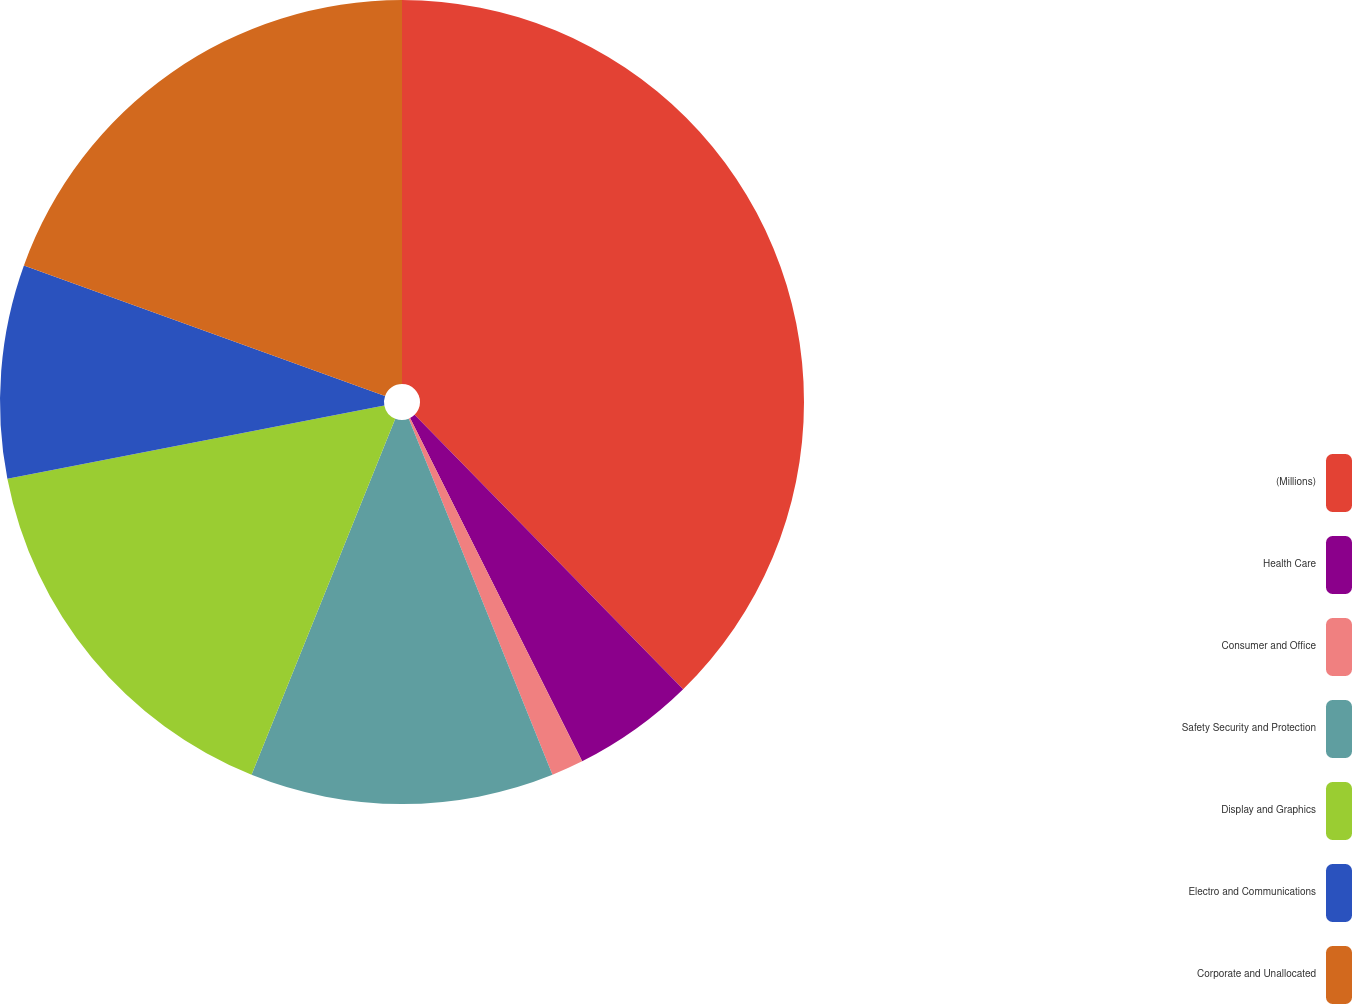<chart> <loc_0><loc_0><loc_500><loc_500><pie_chart><fcel>(Millions)<fcel>Health Care<fcel>Consumer and Office<fcel>Safety Security and Protection<fcel>Display and Graphics<fcel>Electro and Communications<fcel>Corporate and Unallocated<nl><fcel>37.67%<fcel>4.93%<fcel>1.29%<fcel>12.21%<fcel>15.84%<fcel>8.57%<fcel>19.48%<nl></chart> 